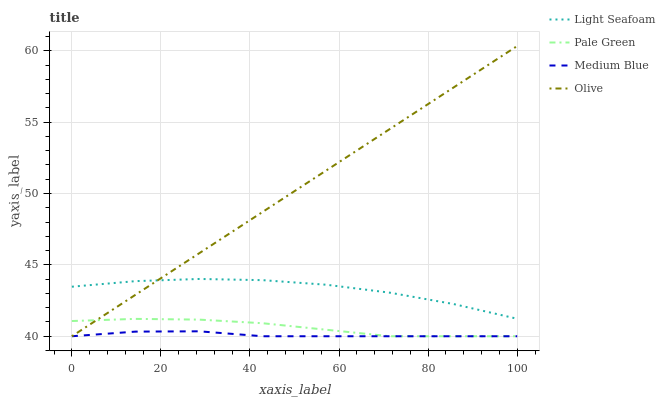Does Medium Blue have the minimum area under the curve?
Answer yes or no. Yes. Does Olive have the maximum area under the curve?
Answer yes or no. Yes. Does Pale Green have the minimum area under the curve?
Answer yes or no. No. Does Pale Green have the maximum area under the curve?
Answer yes or no. No. Is Olive the smoothest?
Answer yes or no. Yes. Is Light Seafoam the roughest?
Answer yes or no. Yes. Is Pale Green the smoothest?
Answer yes or no. No. Is Pale Green the roughest?
Answer yes or no. No. Does Olive have the lowest value?
Answer yes or no. Yes. Does Light Seafoam have the lowest value?
Answer yes or no. No. Does Olive have the highest value?
Answer yes or no. Yes. Does Pale Green have the highest value?
Answer yes or no. No. Is Medium Blue less than Light Seafoam?
Answer yes or no. Yes. Is Light Seafoam greater than Medium Blue?
Answer yes or no. Yes. Does Medium Blue intersect Olive?
Answer yes or no. Yes. Is Medium Blue less than Olive?
Answer yes or no. No. Is Medium Blue greater than Olive?
Answer yes or no. No. Does Medium Blue intersect Light Seafoam?
Answer yes or no. No. 